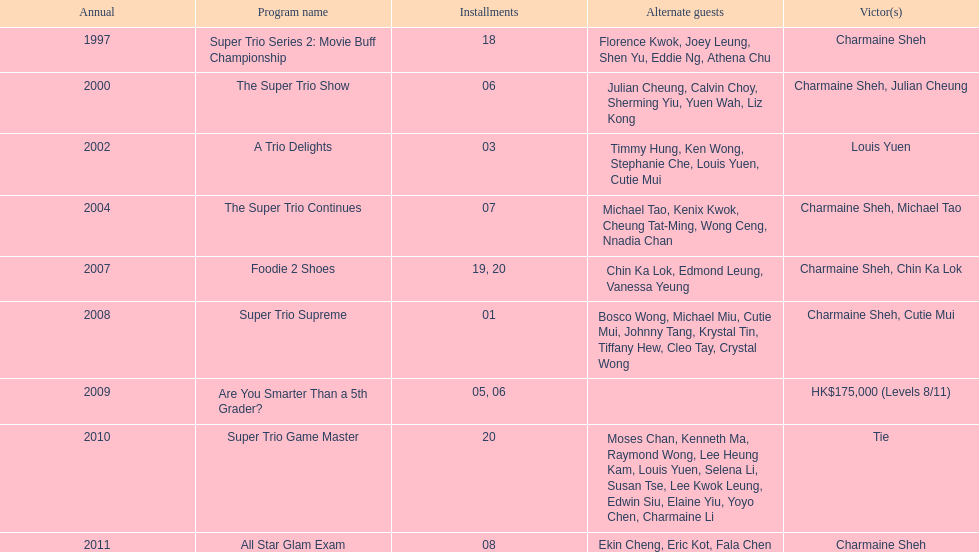How long has it been since chermaine sheh first appeared on a variety show? 17 years. 